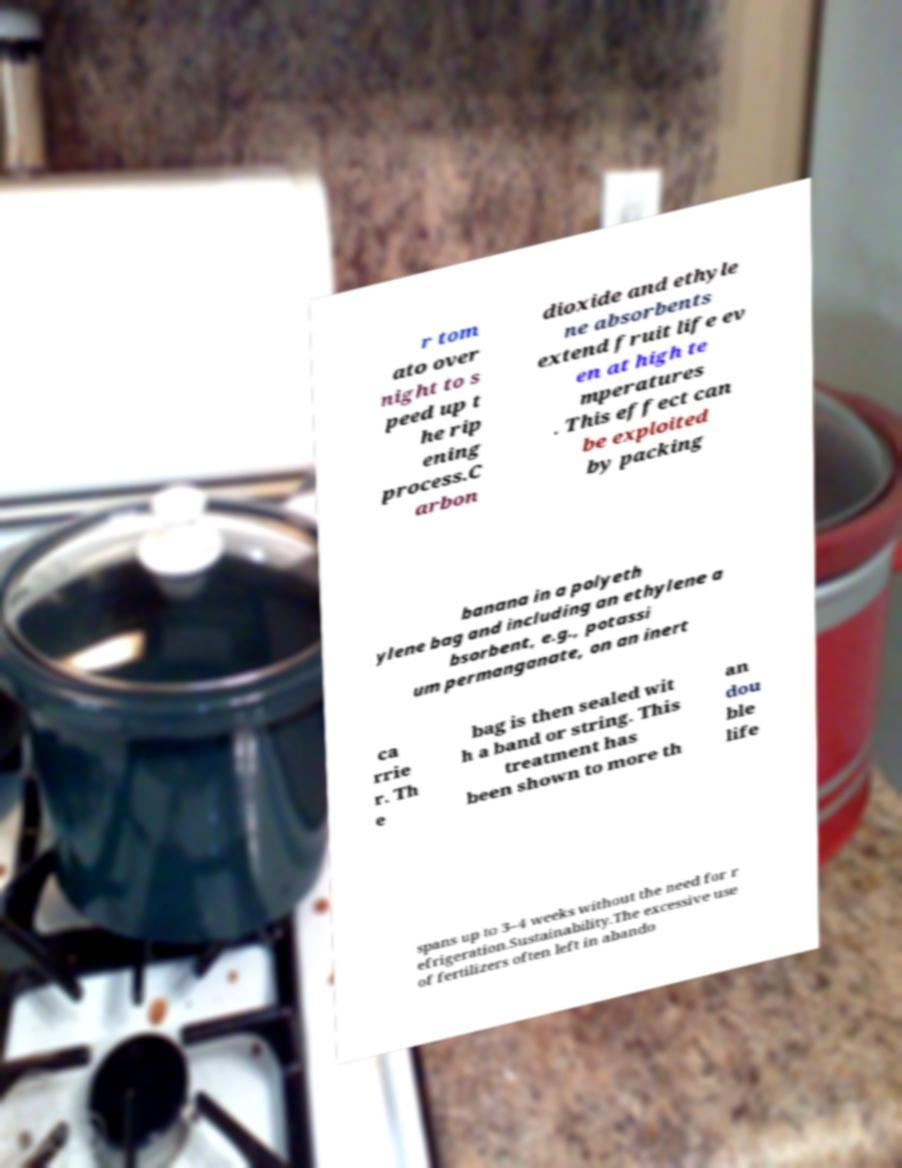There's text embedded in this image that I need extracted. Can you transcribe it verbatim? r tom ato over night to s peed up t he rip ening process.C arbon dioxide and ethyle ne absorbents extend fruit life ev en at high te mperatures . This effect can be exploited by packing banana in a polyeth ylene bag and including an ethylene a bsorbent, e.g., potassi um permanganate, on an inert ca rrie r. Th e bag is then sealed wit h a band or string. This treatment has been shown to more th an dou ble life spans up to 3–4 weeks without the need for r efrigeration.Sustainability.The excessive use of fertilizers often left in abando 